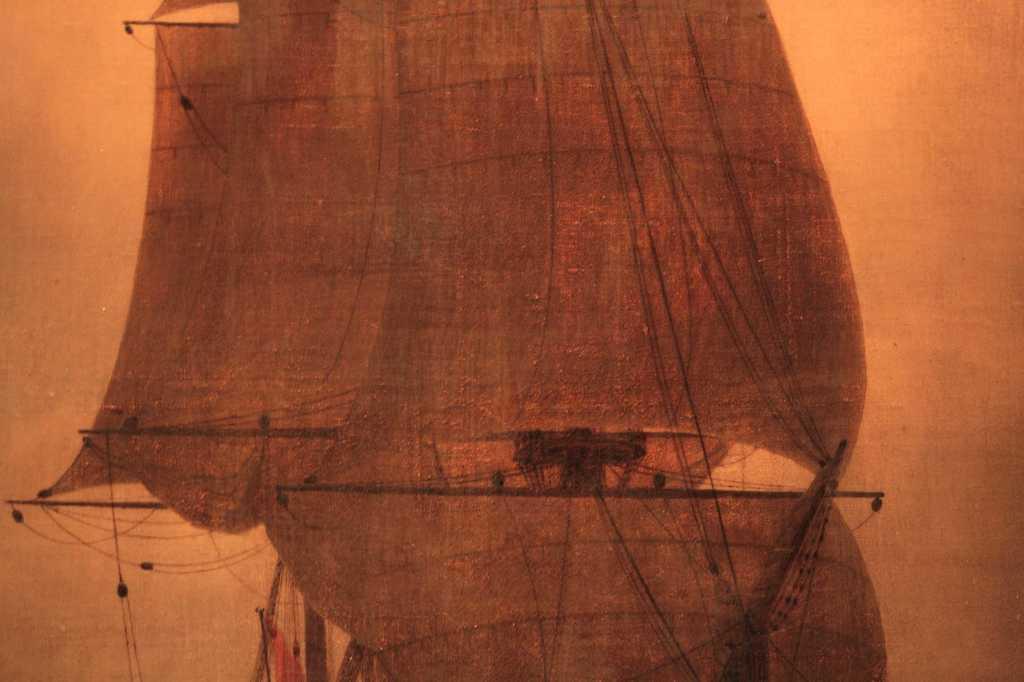Describe this image in one or two sentences. This is a picture of an art of a ship. 